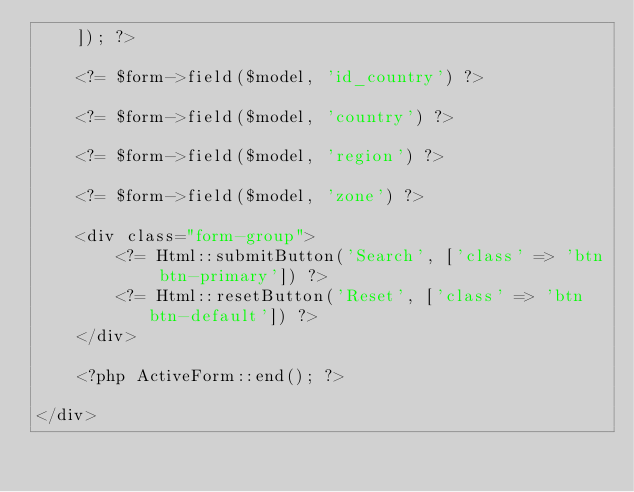<code> <loc_0><loc_0><loc_500><loc_500><_PHP_>    ]); ?>

    <?= $form->field($model, 'id_country') ?>

    <?= $form->field($model, 'country') ?>

    <?= $form->field($model, 'region') ?>

    <?= $form->field($model, 'zone') ?>

    <div class="form-group">
        <?= Html::submitButton('Search', ['class' => 'btn btn-primary']) ?>
        <?= Html::resetButton('Reset', ['class' => 'btn btn-default']) ?>
    </div>

    <?php ActiveForm::end(); ?>

</div>
</code> 